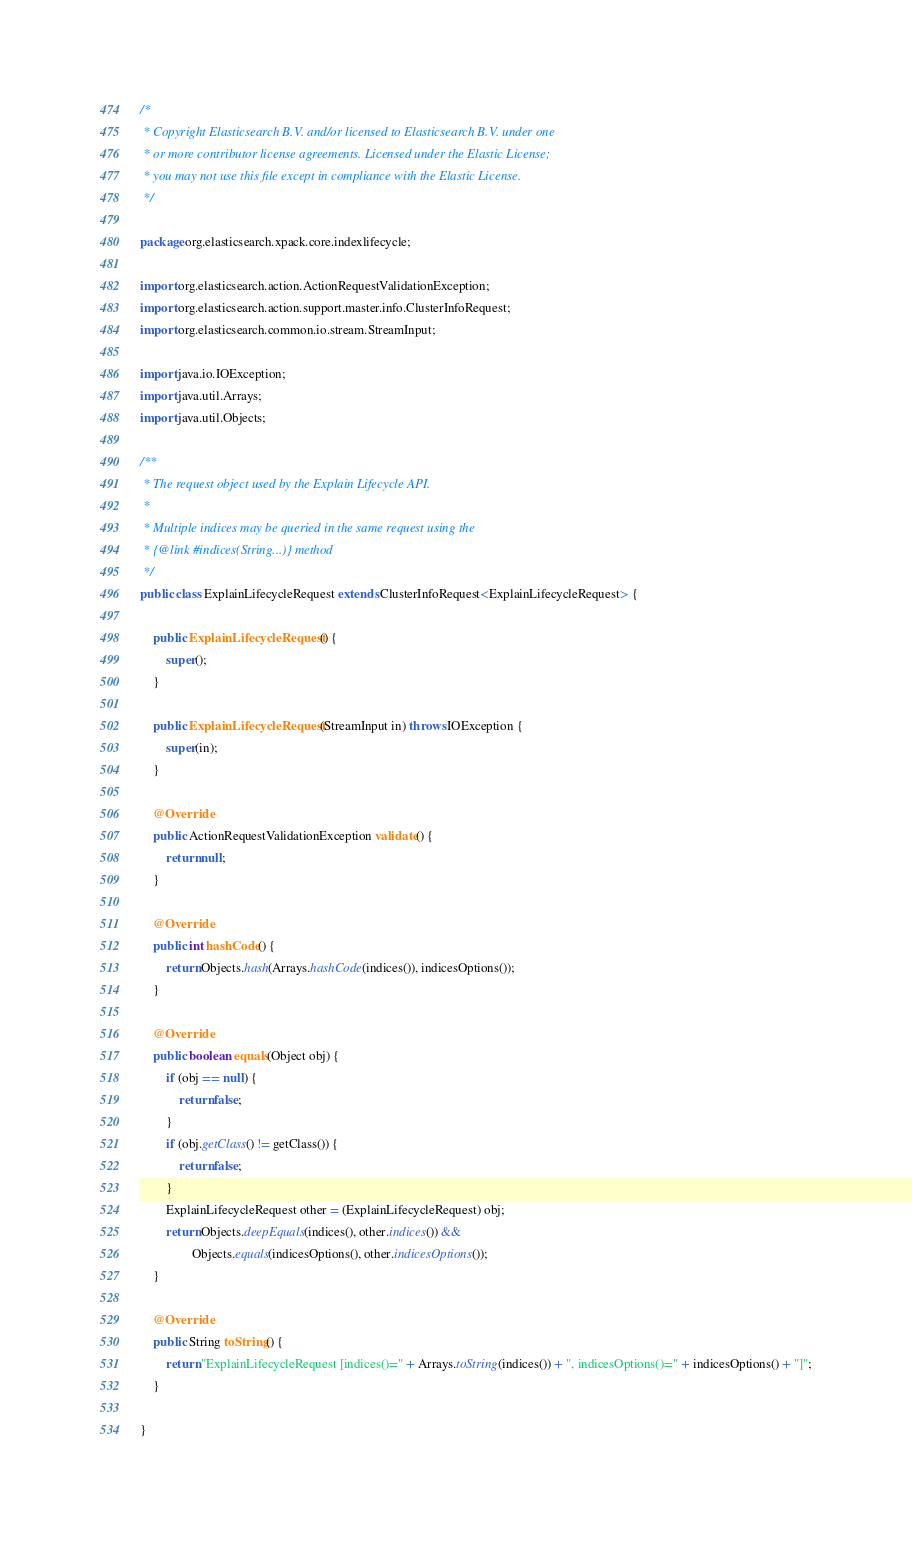Convert code to text. <code><loc_0><loc_0><loc_500><loc_500><_Java_>/*
 * Copyright Elasticsearch B.V. and/or licensed to Elasticsearch B.V. under one
 * or more contributor license agreements. Licensed under the Elastic License;
 * you may not use this file except in compliance with the Elastic License.
 */

package org.elasticsearch.xpack.core.indexlifecycle;

import org.elasticsearch.action.ActionRequestValidationException;
import org.elasticsearch.action.support.master.info.ClusterInfoRequest;
import org.elasticsearch.common.io.stream.StreamInput;

import java.io.IOException;
import java.util.Arrays;
import java.util.Objects;

/**
 * The request object used by the Explain Lifecycle API.
 * 
 * Multiple indices may be queried in the same request using the
 * {@link #indices(String...)} method
 */
public class ExplainLifecycleRequest extends ClusterInfoRequest<ExplainLifecycleRequest> {

    public ExplainLifecycleRequest() {
        super();
    }

    public ExplainLifecycleRequest(StreamInput in) throws IOException {
        super(in);
    }

    @Override
    public ActionRequestValidationException validate() {
        return null;
    }

    @Override
    public int hashCode() {
        return Objects.hash(Arrays.hashCode(indices()), indicesOptions());
    }

    @Override
    public boolean equals(Object obj) {
        if (obj == null) {
            return false;
        }
        if (obj.getClass() != getClass()) {
            return false;
        }
        ExplainLifecycleRequest other = (ExplainLifecycleRequest) obj;
        return Objects.deepEquals(indices(), other.indices()) &&
                Objects.equals(indicesOptions(), other.indicesOptions());
    }

    @Override
    public String toString() {
        return "ExplainLifecycleRequest [indices()=" + Arrays.toString(indices()) + ", indicesOptions()=" + indicesOptions() + "]";
    }

}
</code> 